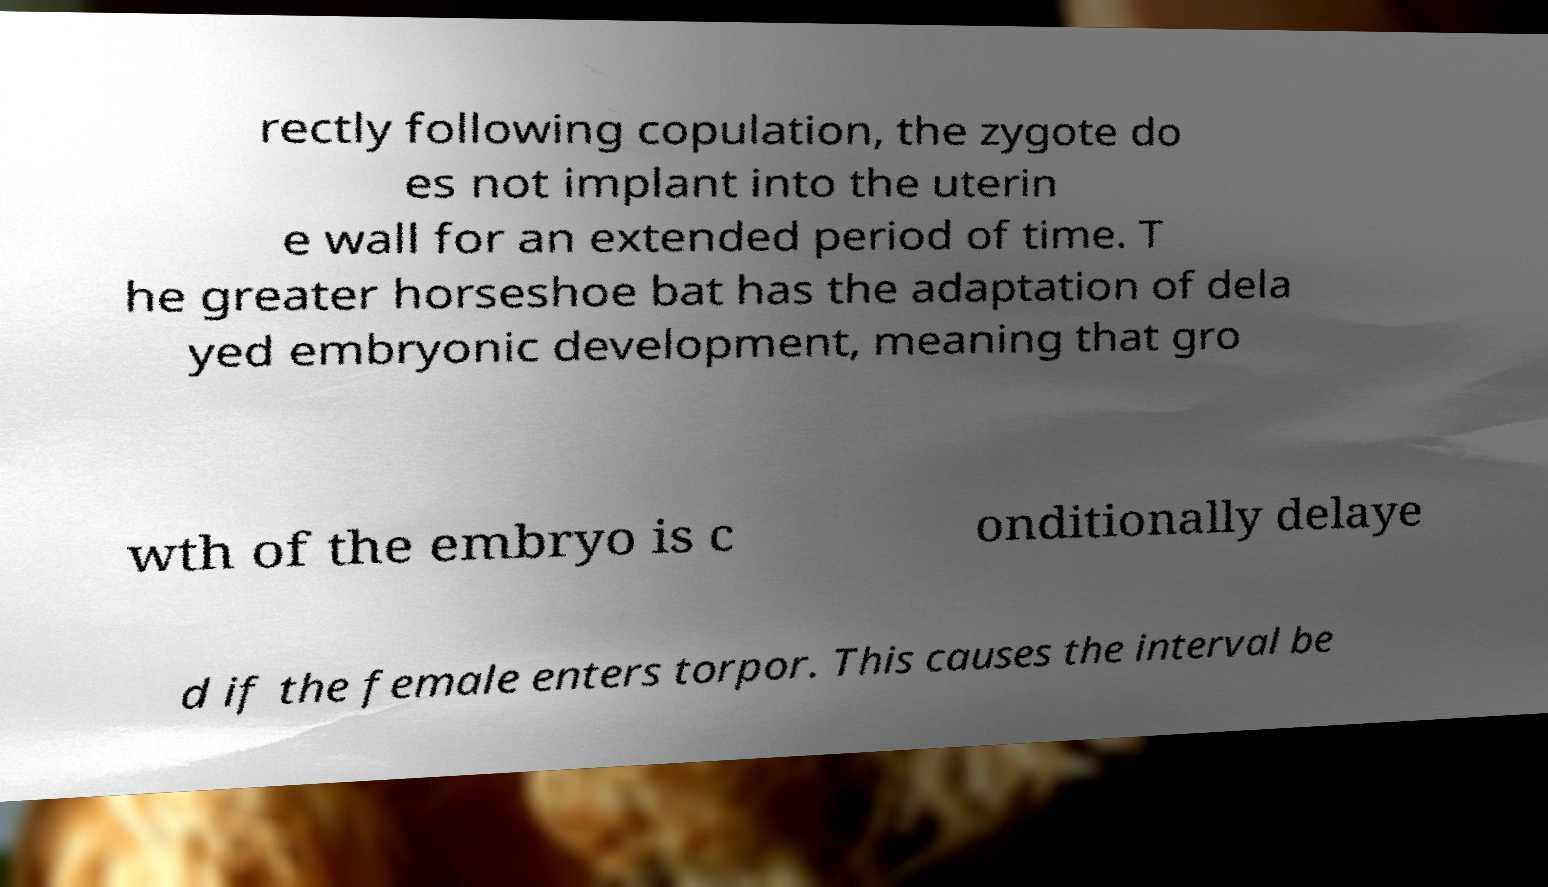What messages or text are displayed in this image? I need them in a readable, typed format. rectly following copulation, the zygote do es not implant into the uterin e wall for an extended period of time. T he greater horseshoe bat has the adaptation of dela yed embryonic development, meaning that gro wth of the embryo is c onditionally delaye d if the female enters torpor. This causes the interval be 